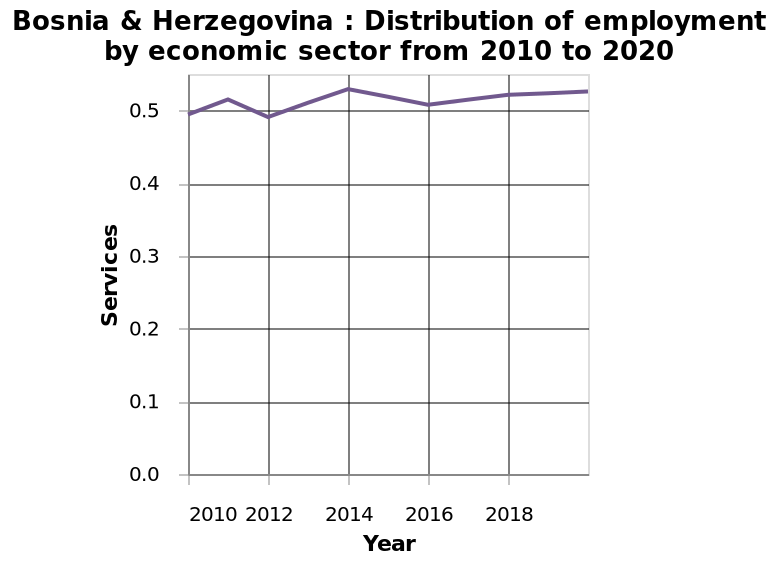<image>
Has there been a significant change in employment rates since 2010?  No, employment rates have not changed much since 2010. What does the x-axis measure in the line plot? The x-axis measures the year in the line plot representing the distribution of employment in Bosnia & Herzegovina from 2010 to 2020. Can it be said that employment rates have remained constant since 2010?  Yes, employment rates have remained relatively constant since 2010. 